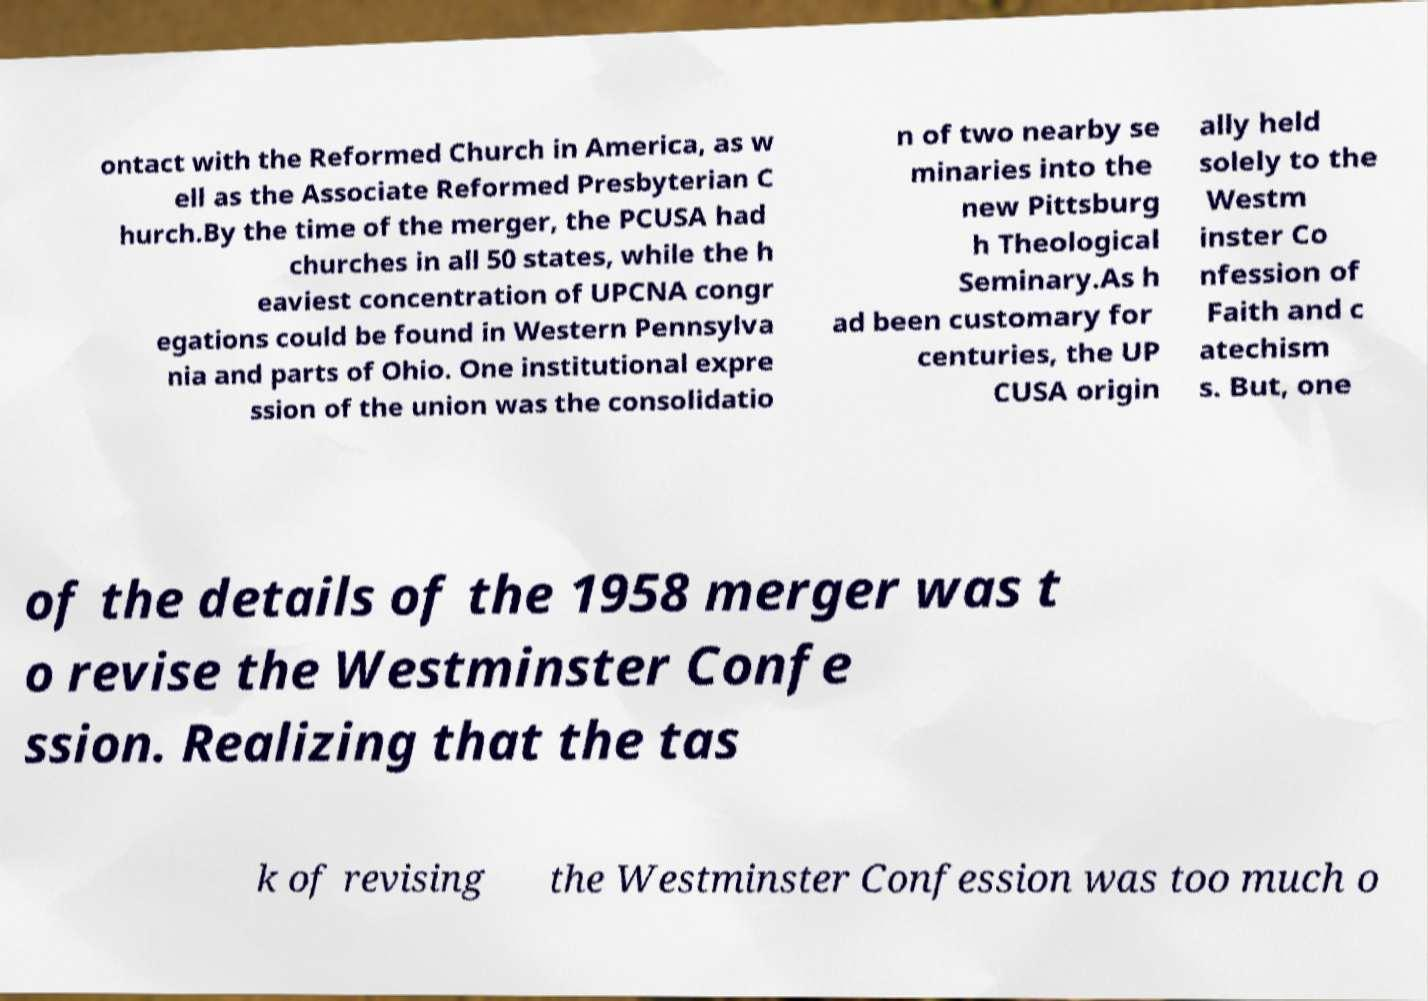Can you read and provide the text displayed in the image?This photo seems to have some interesting text. Can you extract and type it out for me? ontact with the Reformed Church in America, as w ell as the Associate Reformed Presbyterian C hurch.By the time of the merger, the PCUSA had churches in all 50 states, while the h eaviest concentration of UPCNA congr egations could be found in Western Pennsylva nia and parts of Ohio. One institutional expre ssion of the union was the consolidatio n of two nearby se minaries into the new Pittsburg h Theological Seminary.As h ad been customary for centuries, the UP CUSA origin ally held solely to the Westm inster Co nfession of Faith and c atechism s. But, one of the details of the 1958 merger was t o revise the Westminster Confe ssion. Realizing that the tas k of revising the Westminster Confession was too much o 